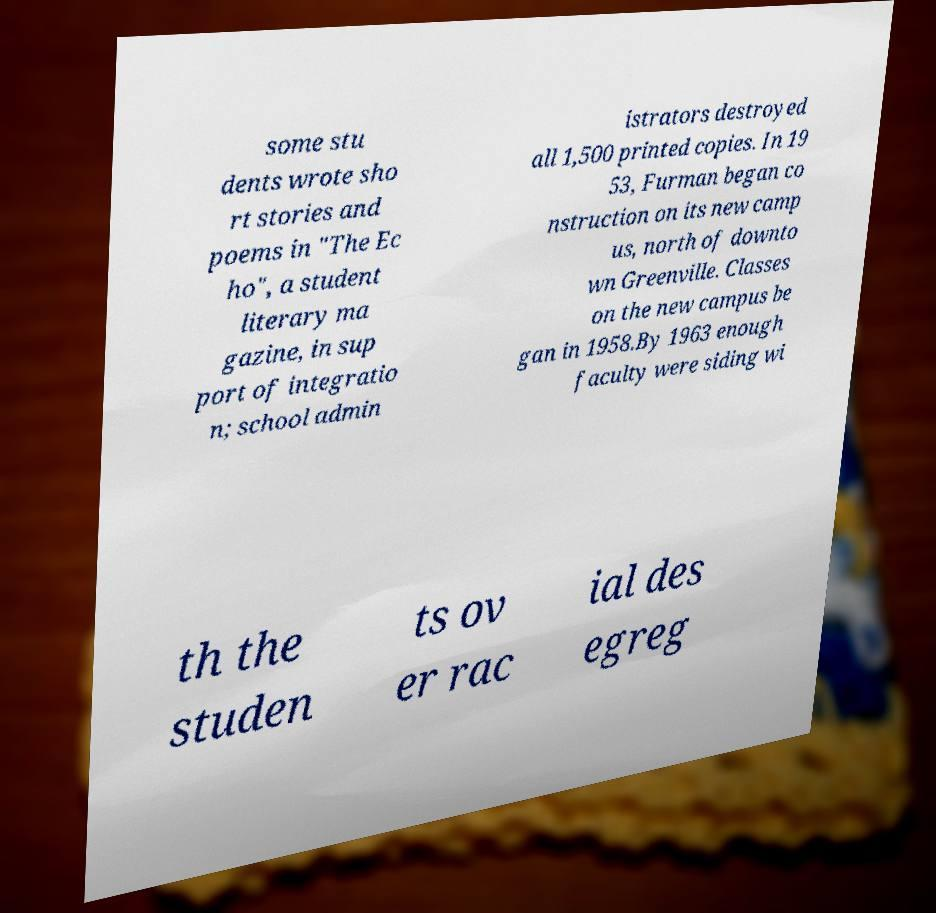There's text embedded in this image that I need extracted. Can you transcribe it verbatim? some stu dents wrote sho rt stories and poems in "The Ec ho", a student literary ma gazine, in sup port of integratio n; school admin istrators destroyed all 1,500 printed copies. In 19 53, Furman began co nstruction on its new camp us, north of downto wn Greenville. Classes on the new campus be gan in 1958.By 1963 enough faculty were siding wi th the studen ts ov er rac ial des egreg 